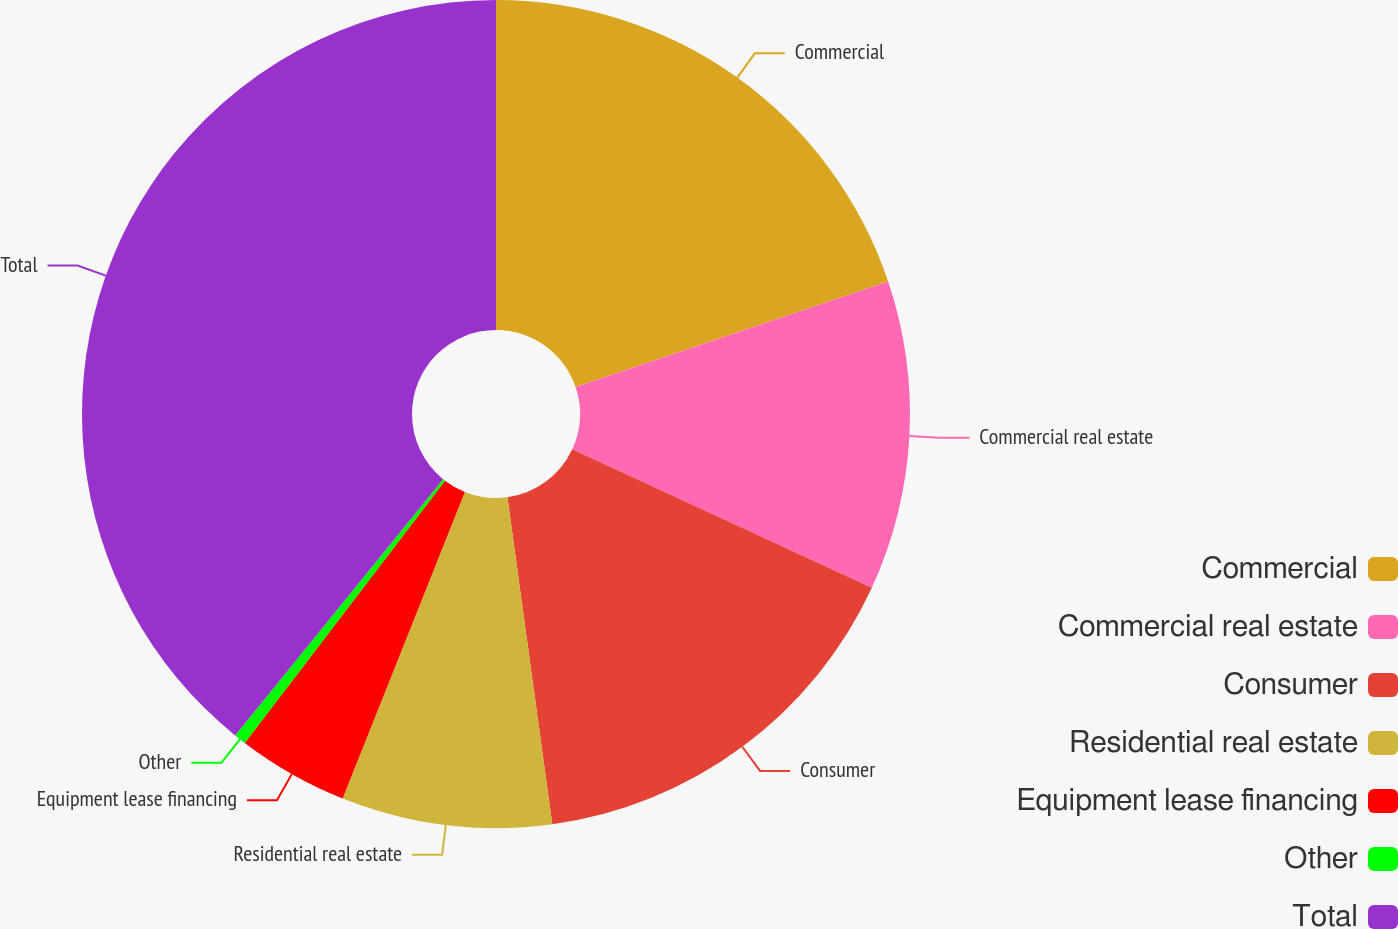Convert chart to OTSL. <chart><loc_0><loc_0><loc_500><loc_500><pie_chart><fcel>Commercial<fcel>Commercial real estate<fcel>Consumer<fcel>Residential real estate<fcel>Equipment lease financing<fcel>Other<fcel>Total<nl><fcel>19.81%<fcel>12.08%<fcel>15.94%<fcel>8.21%<fcel>4.34%<fcel>0.47%<fcel>39.15%<nl></chart> 